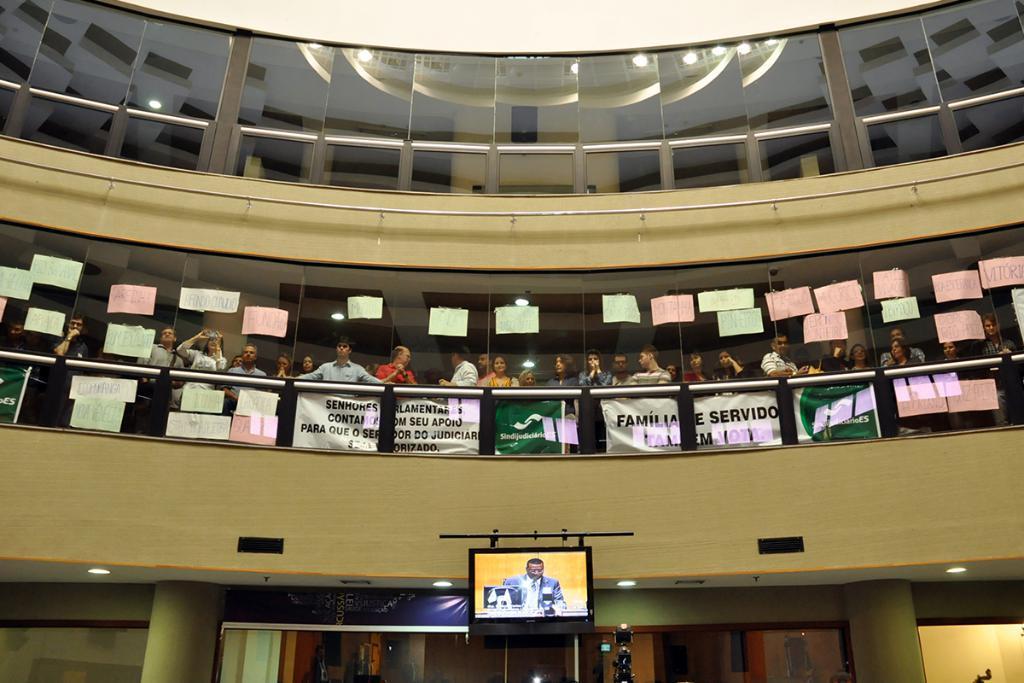Describe this image in one or two sentences. Inside the building there is a television fit to the wall and above the wall there is a railing and behind the railing there are many people, they are standing and in front of the railing there are a lot of posters and there are some papers attached to the glasses behind the people. 